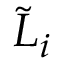Convert formula to latex. <formula><loc_0><loc_0><loc_500><loc_500>{ \tilde { L } } _ { i }</formula> 